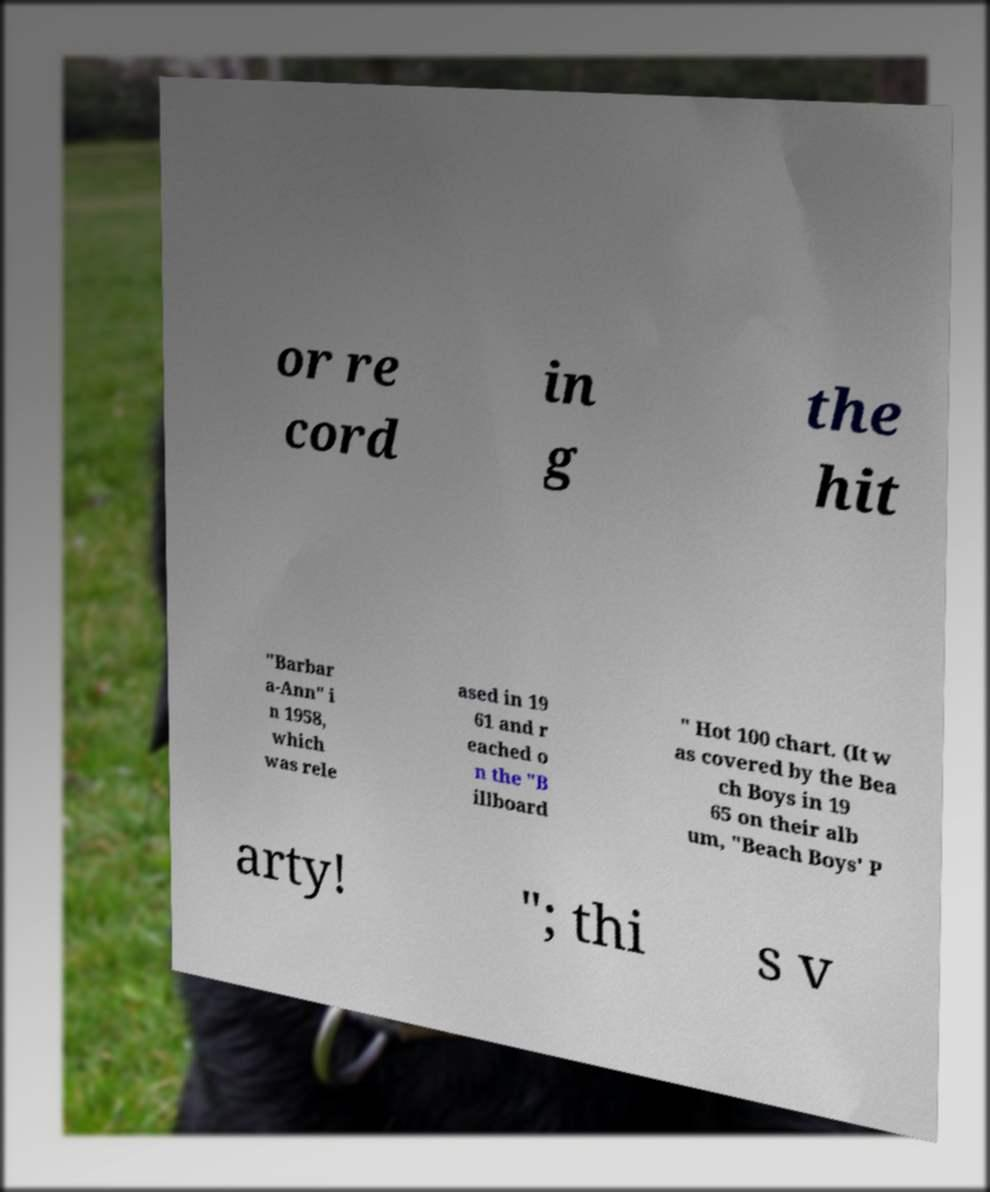Can you read and provide the text displayed in the image?This photo seems to have some interesting text. Can you extract and type it out for me? or re cord in g the hit "Barbar a-Ann" i n 1958, which was rele ased in 19 61 and r eached o n the "B illboard " Hot 100 chart. (It w as covered by the Bea ch Boys in 19 65 on their alb um, "Beach Boys' P arty! "; thi s v 